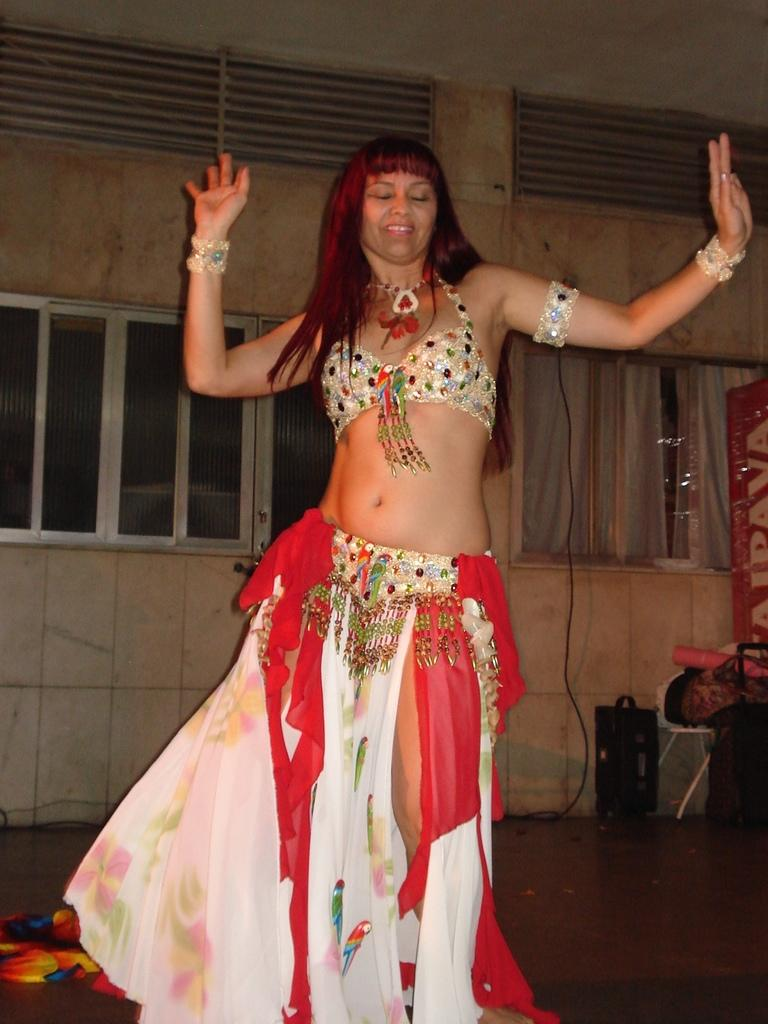Who is the main subject in the image? There is a woman in the image. What is the woman wearing? The woman is wearing a gown. What activity is the woman engaged in? The woman is doing belly dance. What can be seen in the background of the image? There are windows on the wall in the background of the image. What type of muscle is being flexed by the woman in the image? The image does not show the woman flexing any muscles; she is doing belly dance. 